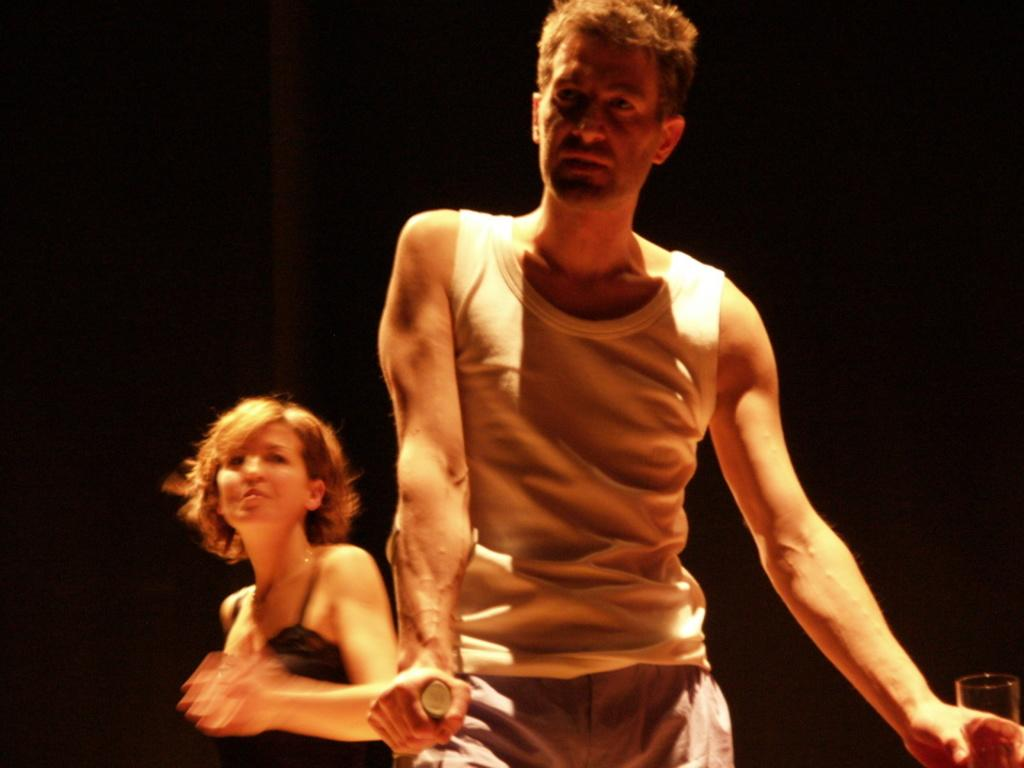What is the man in the image holding? The man is holding a glass in the image. What is the woman in the image wearing? The woman is wearing a black top in the image. Can you describe the background of the image? The background of the image appears to be dark. How many people are present in the image? There are two people in the image, a man and a woman. What type of quilt is being used to cover the eyes of the man in the image? There is no quilt or any indication of the man's eyes being covered in the image. 